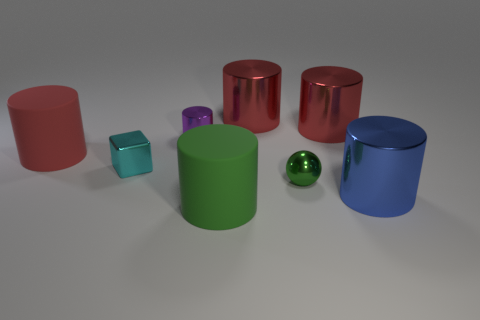Are there any patterns or repetitions in the shapes of the objects, and what might that indicate? Yes, there's a pattern of cylindrical shapes repeated throughout the image with varying heights and colors. This repetition may indicate a study in perspective, volume, and the visual effect of uniform shapes in different sizes. It might also serve an instructional purpose or as part of a visual composition exercise. 